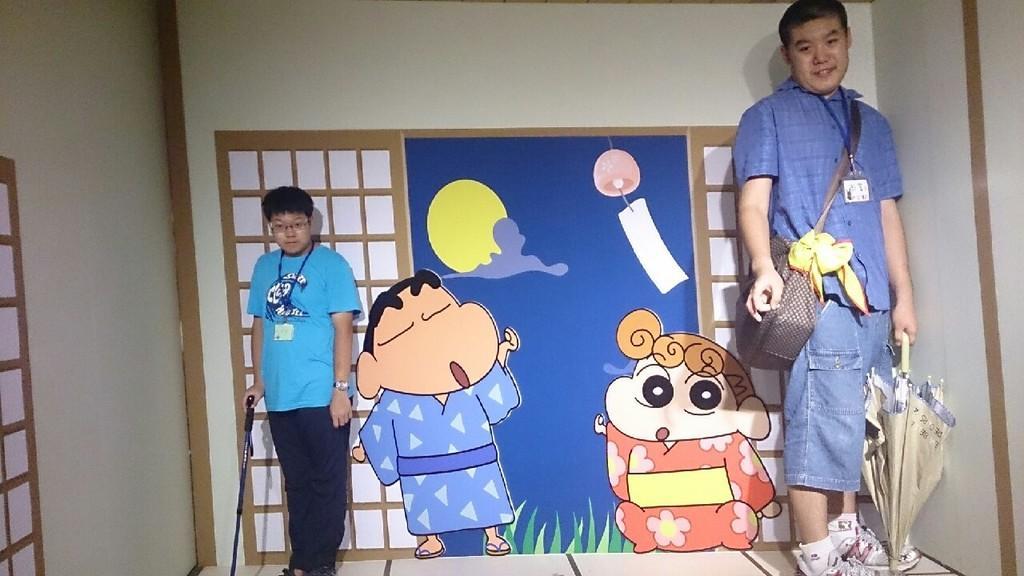Please provide a concise description of this image. In the picture we can see two men are standing on the either side of the wall, one man is short and holding a stick and one man is tall and he is with bag and ID card and holding an umbrella and to the wall we can see a cartoon pictures. 